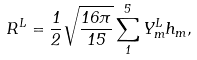<formula> <loc_0><loc_0><loc_500><loc_500>R ^ { L } = \frac { 1 } { 2 } \sqrt { \frac { 1 6 \pi } { 1 5 } } \sum ^ { 5 } _ { 1 } Y _ { m } ^ { L } h _ { m } ,</formula> 